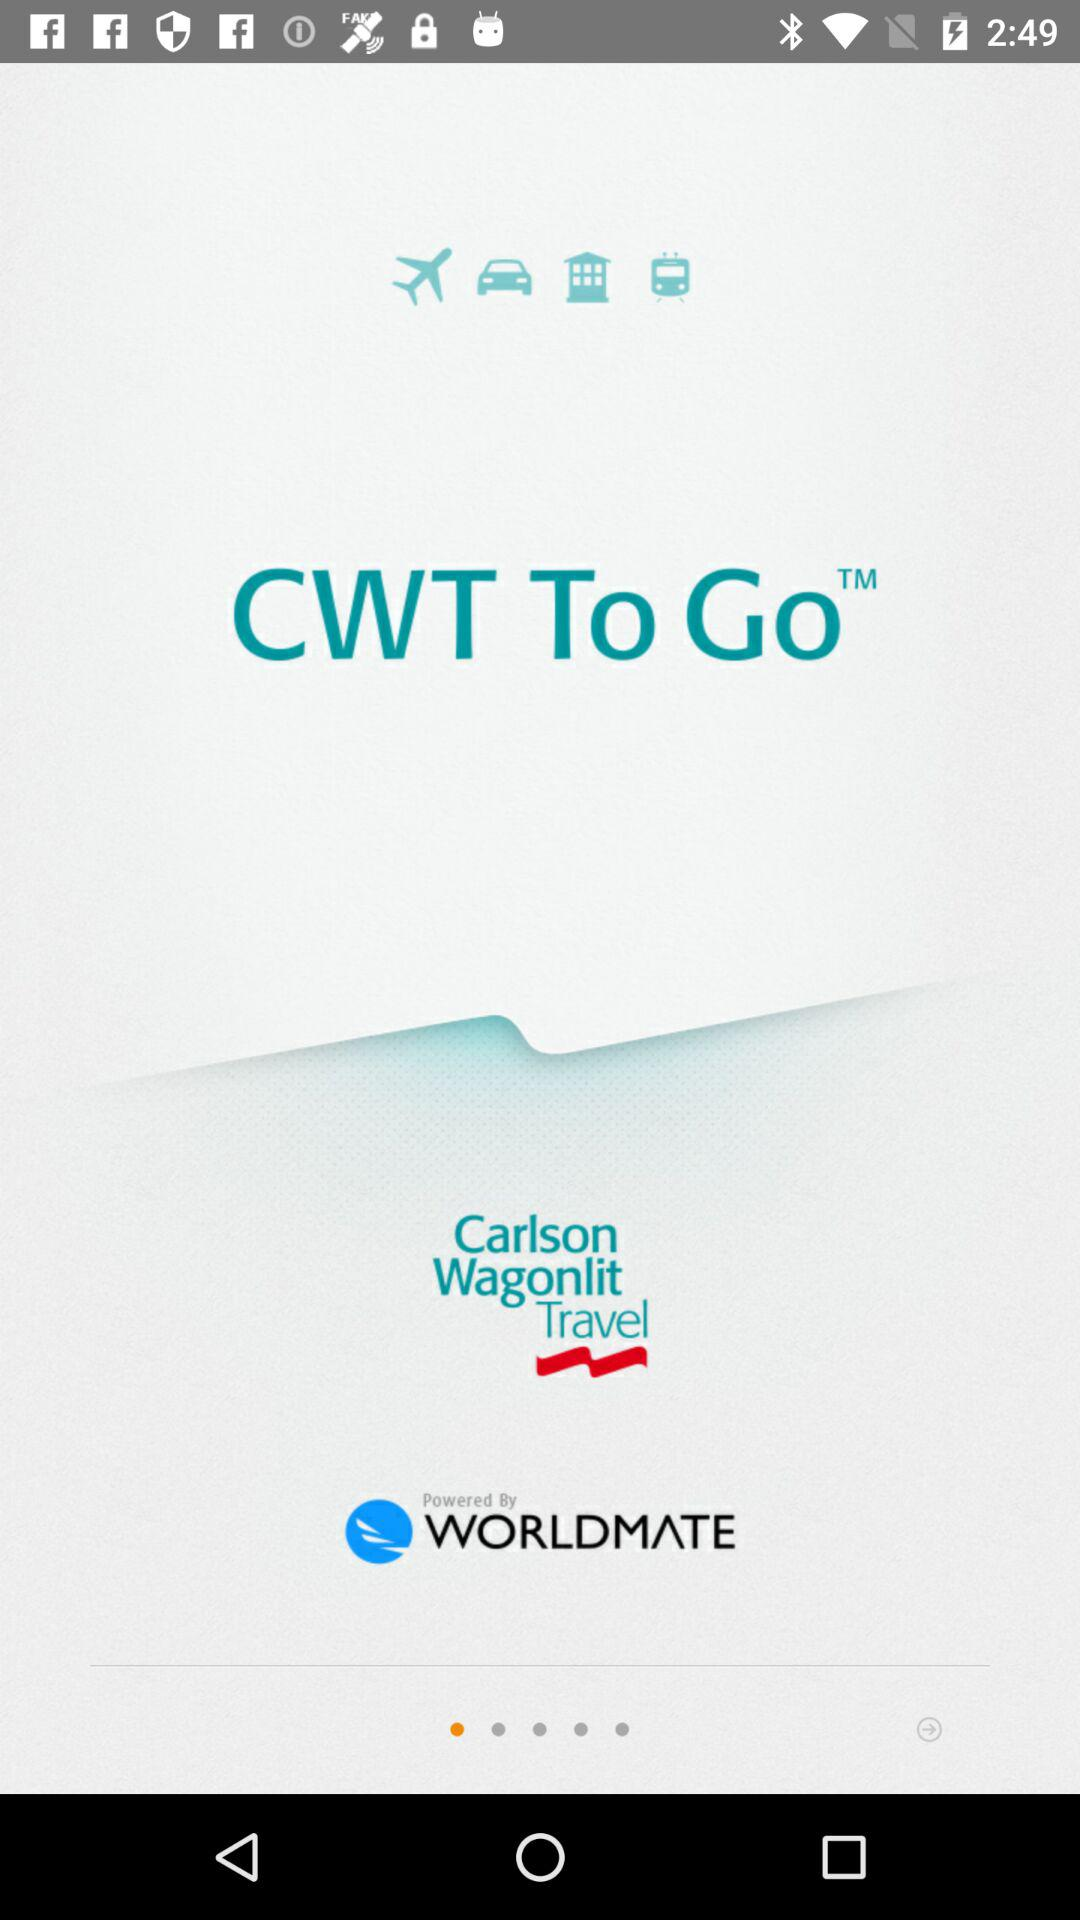What is the name of the application? The name of the application is "CWT To Go". 